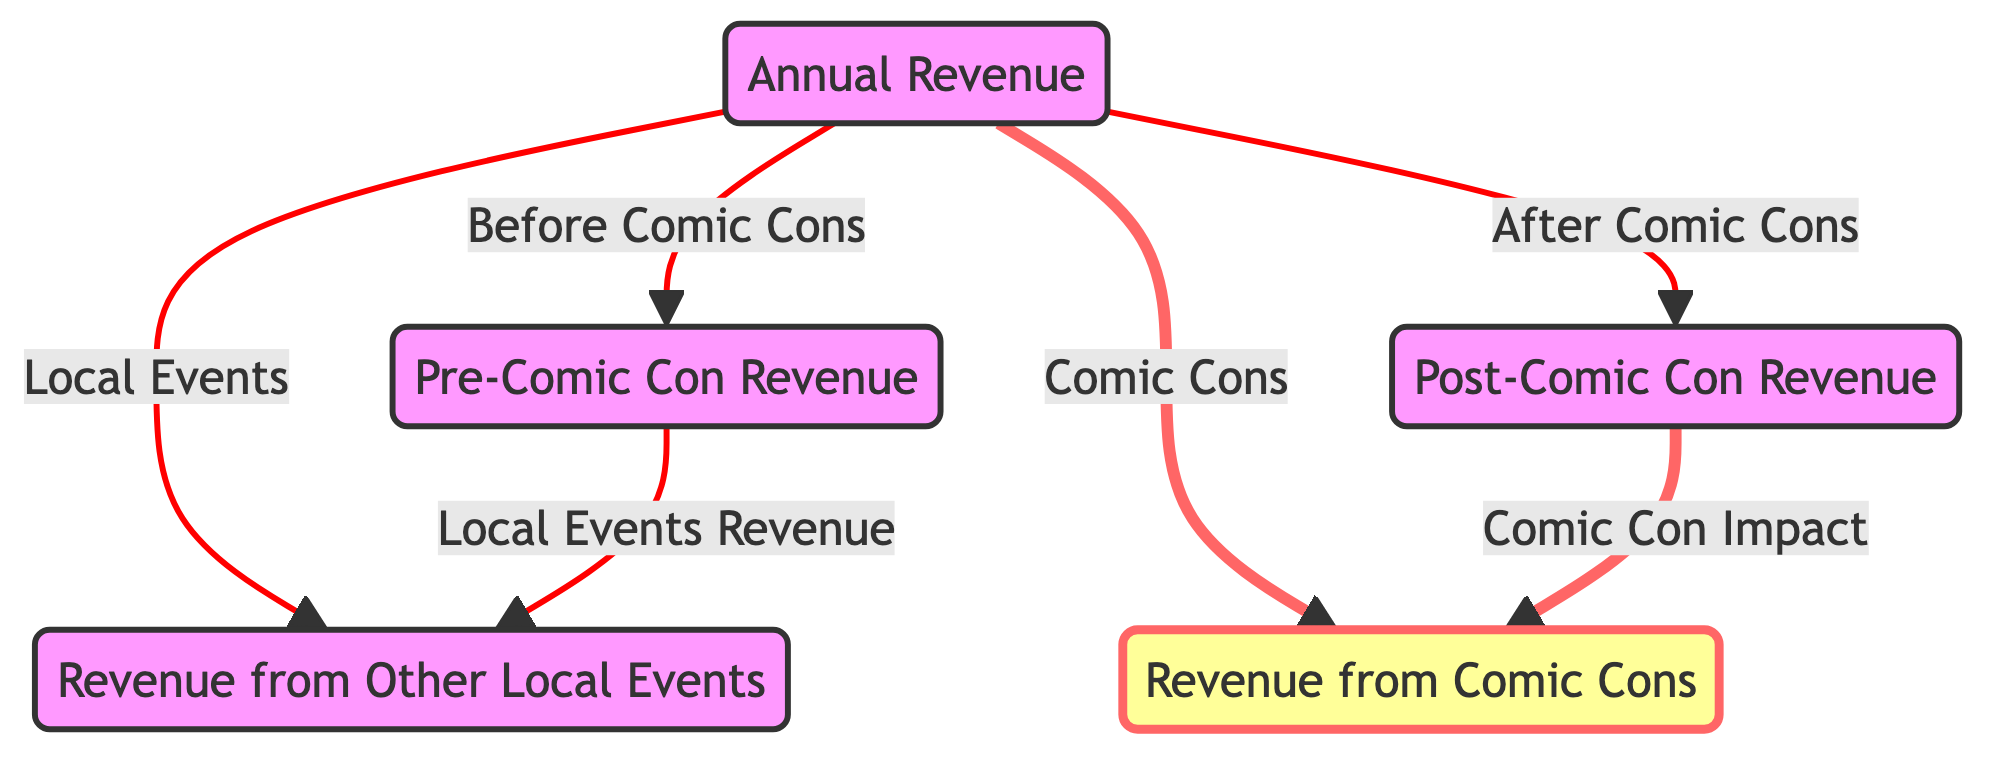What are the four main nodes connected to Annual Revenue? The diagram shows four main nodes connected to "Annual Revenue": "Pre-Comic Con Revenue", "Post-Comic Con Revenue", "Revenue from Other Local Events", and "Revenue from Comic Cons". These nodes represent the different sources or divisions of revenue before and after comic cons, and from other local events.
Answer: Pre-Comic Con Revenue, Post-Comic Con Revenue, Revenue from Other Local Events, Revenue from Comic Cons How does revenue from Other Local Events relate to Pre-Comic Con Revenue? According to the diagram, "Revenue from Other Local Events" is a direct output from "Pre-Comic Con Revenue", which means that it can be considered part of the overall revenue before comic cons occur. This indicates that local events contribute to revenue before any impact from comic cons is taken into account.
Answer: Direct output What type of impact do Comic Cons have on Annual Revenue? The diagram indicates that Comic Cons have a designated impact on "Post-Comic Con Revenue". The presence of the distinct line style (thicker stroke in red) emphasizes the significance of Comic Cons in relation to the revenue after these events occur.
Answer: Significant How many total nodes are there in the diagram? Counting from the diagram, there are five total nodes connected directly to "Annual Revenue": "Pre-Comic Con Revenue", "Post-Comic Con Revenue", "Revenue from Other Local Events", and "Revenue from Comic Cons". Therefore, the total number of nodes is five.
Answer: Five What is the relationship between Post-Comic Con Revenue and Comic Con Impact? "Post-Comic Con Revenue" is shown in the diagram as affected by "Comic Con Impact", indicating that there is a direct relationship where comic cons influence the overall revenue after their occurrence. The flow points to how comic cons impact revenue after they take place.
Answer: Direct relationship 